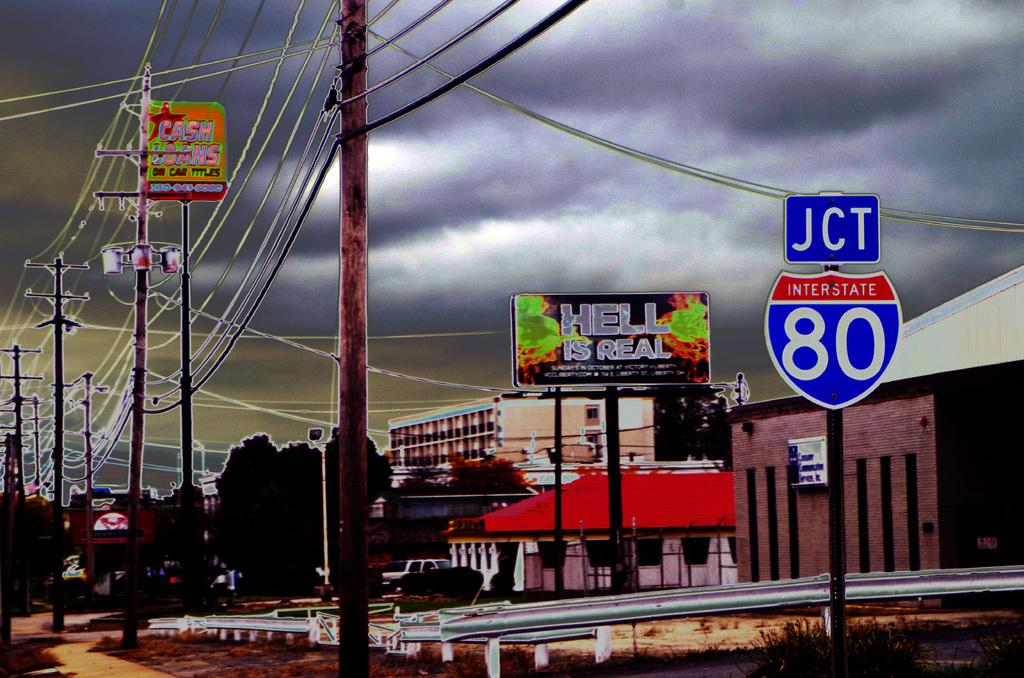<image>
Summarize the visual content of the image. Road sign with the Interstate 80 wrote on it. 